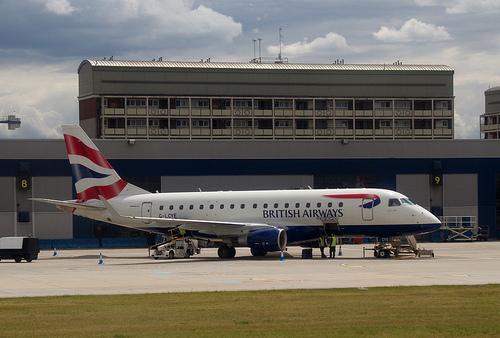How many airplanes can be seen?
Give a very brief answer. 1. 